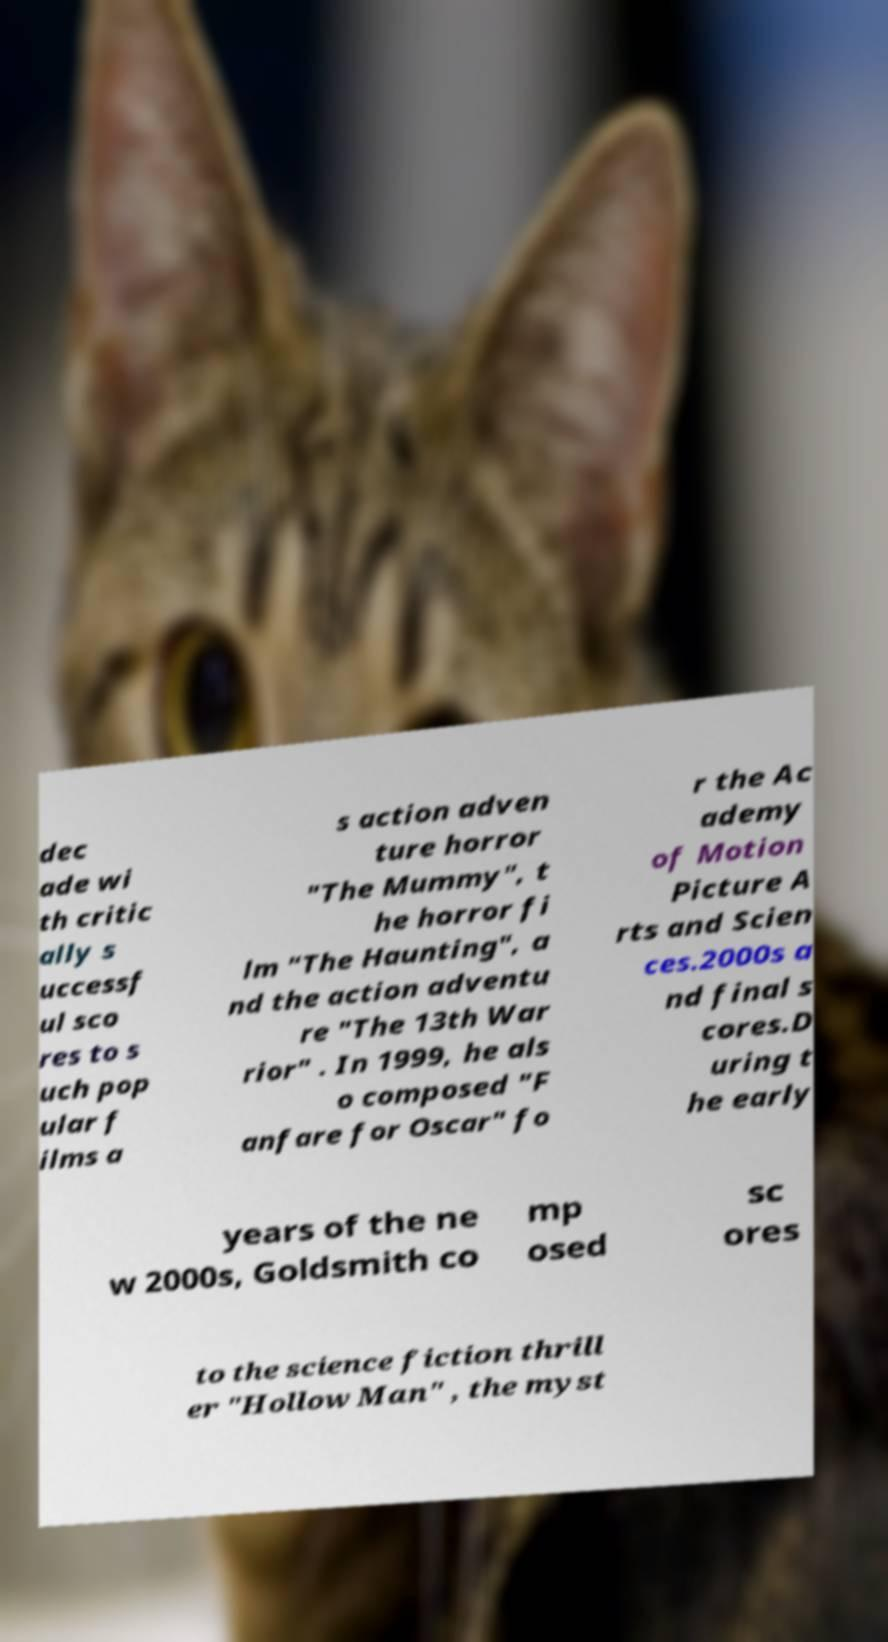For documentation purposes, I need the text within this image transcribed. Could you provide that? dec ade wi th critic ally s uccessf ul sco res to s uch pop ular f ilms a s action adven ture horror "The Mummy", t he horror fi lm "The Haunting", a nd the action adventu re "The 13th War rior" . In 1999, he als o composed "F anfare for Oscar" fo r the Ac ademy of Motion Picture A rts and Scien ces.2000s a nd final s cores.D uring t he early years of the ne w 2000s, Goldsmith co mp osed sc ores to the science fiction thrill er "Hollow Man" , the myst 